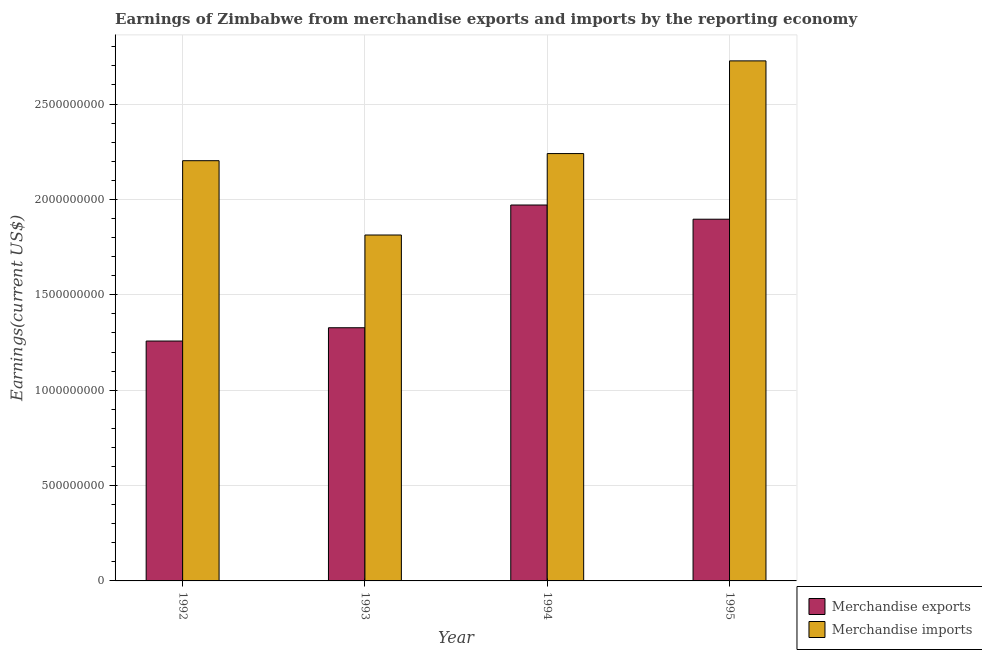How many bars are there on the 1st tick from the right?
Your response must be concise. 2. What is the label of the 3rd group of bars from the left?
Offer a terse response. 1994. What is the earnings from merchandise imports in 1993?
Ensure brevity in your answer.  1.81e+09. Across all years, what is the maximum earnings from merchandise imports?
Provide a succinct answer. 2.73e+09. Across all years, what is the minimum earnings from merchandise imports?
Keep it short and to the point. 1.81e+09. In which year was the earnings from merchandise imports minimum?
Your response must be concise. 1993. What is the total earnings from merchandise imports in the graph?
Provide a succinct answer. 8.98e+09. What is the difference between the earnings from merchandise exports in 1992 and that in 1993?
Your response must be concise. -6.97e+07. What is the difference between the earnings from merchandise imports in 1994 and the earnings from merchandise exports in 1995?
Offer a terse response. -4.86e+08. What is the average earnings from merchandise exports per year?
Your response must be concise. 1.61e+09. What is the ratio of the earnings from merchandise exports in 1994 to that in 1995?
Provide a short and direct response. 1.04. Is the earnings from merchandise imports in 1993 less than that in 1994?
Offer a very short reply. Yes. What is the difference between the highest and the second highest earnings from merchandise imports?
Your response must be concise. 4.86e+08. What is the difference between the highest and the lowest earnings from merchandise imports?
Keep it short and to the point. 9.13e+08. In how many years, is the earnings from merchandise exports greater than the average earnings from merchandise exports taken over all years?
Make the answer very short. 2. How many bars are there?
Your response must be concise. 8. How many years are there in the graph?
Keep it short and to the point. 4. Does the graph contain grids?
Provide a succinct answer. Yes. Where does the legend appear in the graph?
Offer a terse response. Bottom right. How many legend labels are there?
Make the answer very short. 2. What is the title of the graph?
Your response must be concise. Earnings of Zimbabwe from merchandise exports and imports by the reporting economy. Does "Excluding technical cooperation" appear as one of the legend labels in the graph?
Your response must be concise. No. What is the label or title of the Y-axis?
Provide a short and direct response. Earnings(current US$). What is the Earnings(current US$) of Merchandise exports in 1992?
Your response must be concise. 1.26e+09. What is the Earnings(current US$) in Merchandise imports in 1992?
Provide a short and direct response. 2.20e+09. What is the Earnings(current US$) in Merchandise exports in 1993?
Offer a very short reply. 1.33e+09. What is the Earnings(current US$) in Merchandise imports in 1993?
Make the answer very short. 1.81e+09. What is the Earnings(current US$) of Merchandise exports in 1994?
Ensure brevity in your answer.  1.97e+09. What is the Earnings(current US$) in Merchandise imports in 1994?
Offer a terse response. 2.24e+09. What is the Earnings(current US$) in Merchandise exports in 1995?
Your response must be concise. 1.90e+09. What is the Earnings(current US$) of Merchandise imports in 1995?
Offer a terse response. 2.73e+09. Across all years, what is the maximum Earnings(current US$) of Merchandise exports?
Offer a very short reply. 1.97e+09. Across all years, what is the maximum Earnings(current US$) in Merchandise imports?
Offer a very short reply. 2.73e+09. Across all years, what is the minimum Earnings(current US$) in Merchandise exports?
Provide a short and direct response. 1.26e+09. Across all years, what is the minimum Earnings(current US$) in Merchandise imports?
Provide a short and direct response. 1.81e+09. What is the total Earnings(current US$) of Merchandise exports in the graph?
Ensure brevity in your answer.  6.45e+09. What is the total Earnings(current US$) in Merchandise imports in the graph?
Your answer should be compact. 8.98e+09. What is the difference between the Earnings(current US$) in Merchandise exports in 1992 and that in 1993?
Your answer should be very brief. -6.97e+07. What is the difference between the Earnings(current US$) in Merchandise imports in 1992 and that in 1993?
Give a very brief answer. 3.90e+08. What is the difference between the Earnings(current US$) of Merchandise exports in 1992 and that in 1994?
Offer a terse response. -7.13e+08. What is the difference between the Earnings(current US$) in Merchandise imports in 1992 and that in 1994?
Provide a short and direct response. -3.74e+07. What is the difference between the Earnings(current US$) in Merchandise exports in 1992 and that in 1995?
Offer a very short reply. -6.39e+08. What is the difference between the Earnings(current US$) in Merchandise imports in 1992 and that in 1995?
Ensure brevity in your answer.  -5.23e+08. What is the difference between the Earnings(current US$) in Merchandise exports in 1993 and that in 1994?
Keep it short and to the point. -6.43e+08. What is the difference between the Earnings(current US$) in Merchandise imports in 1993 and that in 1994?
Your answer should be very brief. -4.27e+08. What is the difference between the Earnings(current US$) of Merchandise exports in 1993 and that in 1995?
Give a very brief answer. -5.69e+08. What is the difference between the Earnings(current US$) of Merchandise imports in 1993 and that in 1995?
Your answer should be very brief. -9.13e+08. What is the difference between the Earnings(current US$) in Merchandise exports in 1994 and that in 1995?
Your answer should be compact. 7.45e+07. What is the difference between the Earnings(current US$) of Merchandise imports in 1994 and that in 1995?
Your answer should be very brief. -4.86e+08. What is the difference between the Earnings(current US$) in Merchandise exports in 1992 and the Earnings(current US$) in Merchandise imports in 1993?
Give a very brief answer. -5.56e+08. What is the difference between the Earnings(current US$) in Merchandise exports in 1992 and the Earnings(current US$) in Merchandise imports in 1994?
Offer a very short reply. -9.83e+08. What is the difference between the Earnings(current US$) of Merchandise exports in 1992 and the Earnings(current US$) of Merchandise imports in 1995?
Your answer should be very brief. -1.47e+09. What is the difference between the Earnings(current US$) of Merchandise exports in 1993 and the Earnings(current US$) of Merchandise imports in 1994?
Your response must be concise. -9.13e+08. What is the difference between the Earnings(current US$) in Merchandise exports in 1993 and the Earnings(current US$) in Merchandise imports in 1995?
Provide a short and direct response. -1.40e+09. What is the difference between the Earnings(current US$) of Merchandise exports in 1994 and the Earnings(current US$) of Merchandise imports in 1995?
Offer a terse response. -7.56e+08. What is the average Earnings(current US$) of Merchandise exports per year?
Ensure brevity in your answer.  1.61e+09. What is the average Earnings(current US$) in Merchandise imports per year?
Give a very brief answer. 2.25e+09. In the year 1992, what is the difference between the Earnings(current US$) in Merchandise exports and Earnings(current US$) in Merchandise imports?
Your answer should be compact. -9.45e+08. In the year 1993, what is the difference between the Earnings(current US$) of Merchandise exports and Earnings(current US$) of Merchandise imports?
Your answer should be very brief. -4.86e+08. In the year 1994, what is the difference between the Earnings(current US$) of Merchandise exports and Earnings(current US$) of Merchandise imports?
Ensure brevity in your answer.  -2.70e+08. In the year 1995, what is the difference between the Earnings(current US$) of Merchandise exports and Earnings(current US$) of Merchandise imports?
Make the answer very short. -8.30e+08. What is the ratio of the Earnings(current US$) in Merchandise exports in 1992 to that in 1993?
Keep it short and to the point. 0.95. What is the ratio of the Earnings(current US$) in Merchandise imports in 1992 to that in 1993?
Your answer should be compact. 1.21. What is the ratio of the Earnings(current US$) of Merchandise exports in 1992 to that in 1994?
Your answer should be compact. 0.64. What is the ratio of the Earnings(current US$) in Merchandise imports in 1992 to that in 1994?
Your response must be concise. 0.98. What is the ratio of the Earnings(current US$) in Merchandise exports in 1992 to that in 1995?
Your response must be concise. 0.66. What is the ratio of the Earnings(current US$) in Merchandise imports in 1992 to that in 1995?
Give a very brief answer. 0.81. What is the ratio of the Earnings(current US$) in Merchandise exports in 1993 to that in 1994?
Provide a short and direct response. 0.67. What is the ratio of the Earnings(current US$) in Merchandise imports in 1993 to that in 1994?
Your response must be concise. 0.81. What is the ratio of the Earnings(current US$) in Merchandise imports in 1993 to that in 1995?
Make the answer very short. 0.67. What is the ratio of the Earnings(current US$) of Merchandise exports in 1994 to that in 1995?
Keep it short and to the point. 1.04. What is the ratio of the Earnings(current US$) of Merchandise imports in 1994 to that in 1995?
Give a very brief answer. 0.82. What is the difference between the highest and the second highest Earnings(current US$) in Merchandise exports?
Your response must be concise. 7.45e+07. What is the difference between the highest and the second highest Earnings(current US$) of Merchandise imports?
Ensure brevity in your answer.  4.86e+08. What is the difference between the highest and the lowest Earnings(current US$) of Merchandise exports?
Keep it short and to the point. 7.13e+08. What is the difference between the highest and the lowest Earnings(current US$) of Merchandise imports?
Keep it short and to the point. 9.13e+08. 